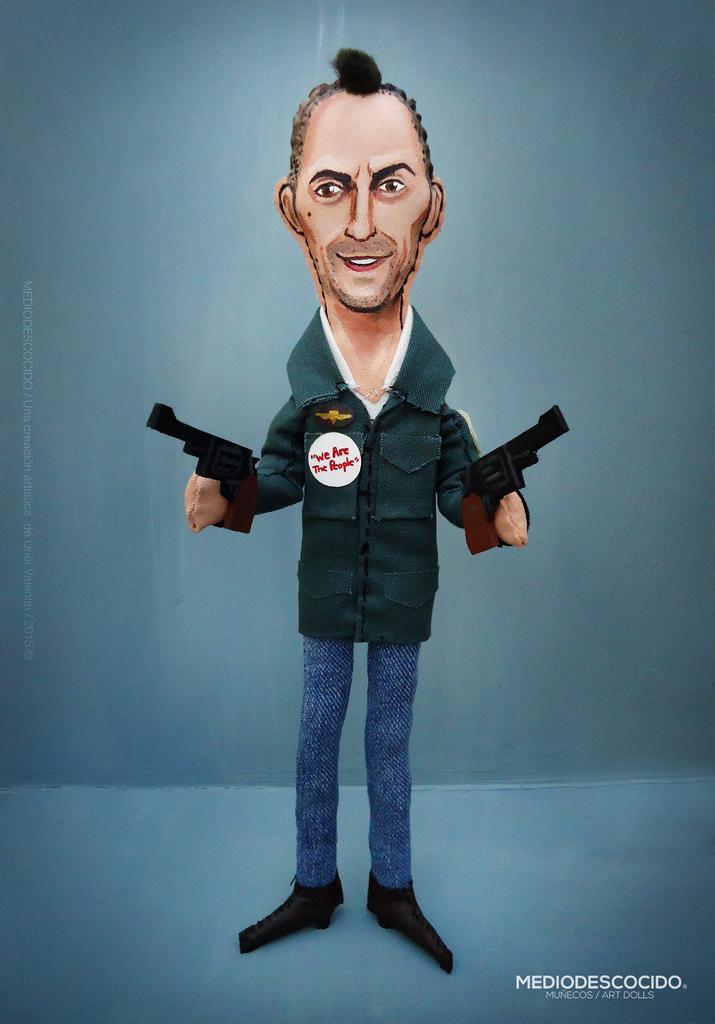Please provide a concise description of this image. In the picture we can see a cartoon man standing on the floor holding two guns in the two hands and he is wearing a green shirt and in the background we can see a wall which is blue in color. 